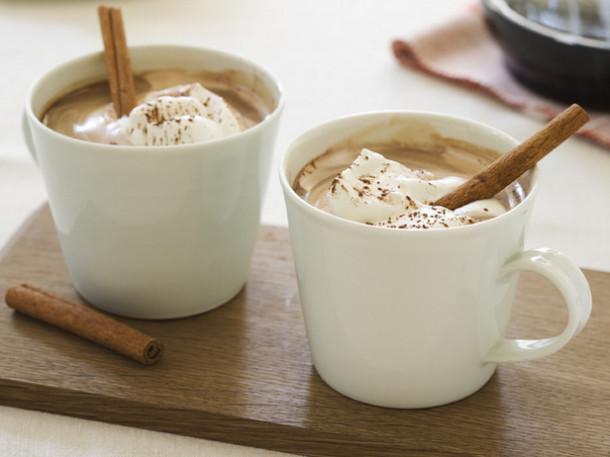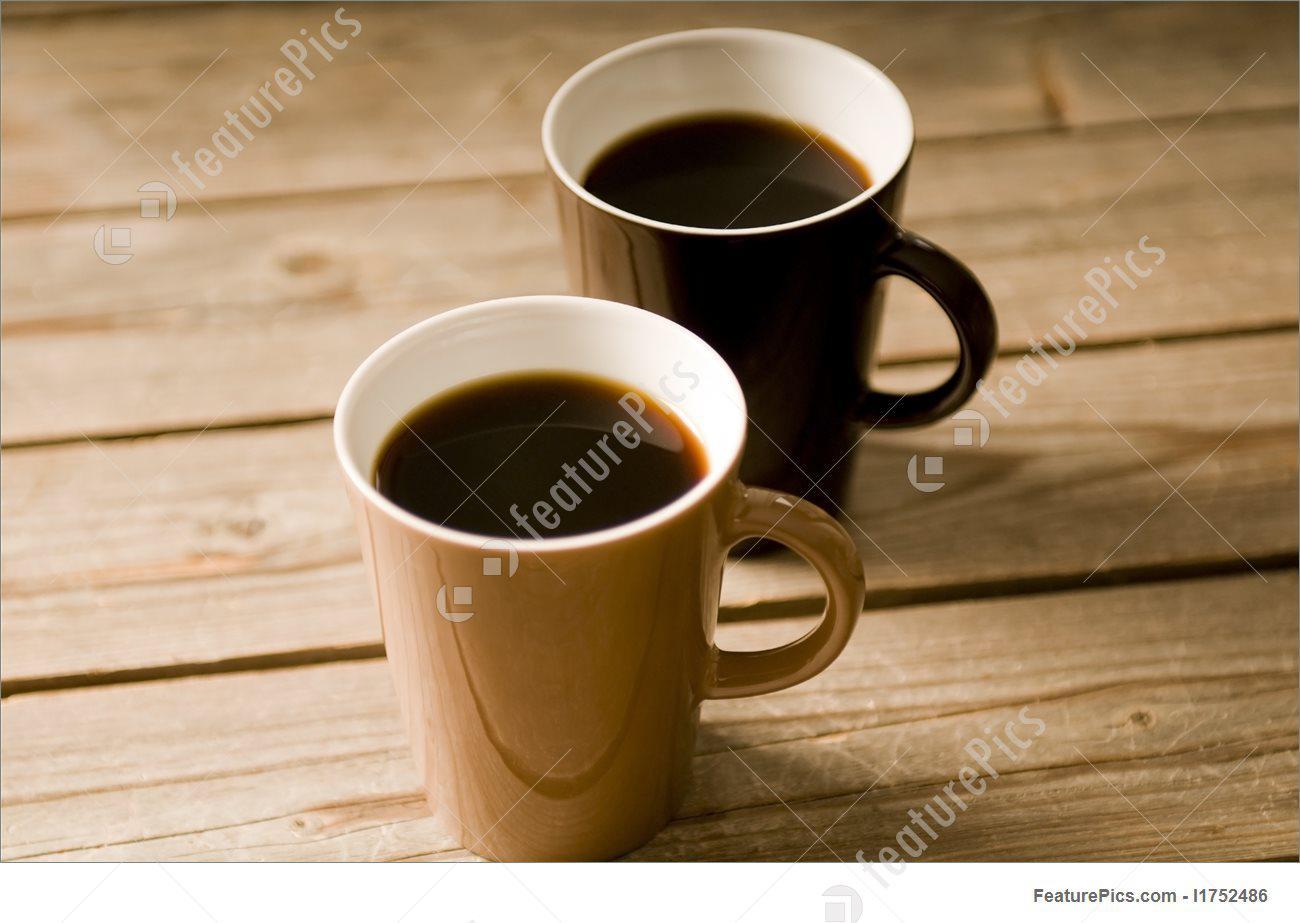The first image is the image on the left, the second image is the image on the right. Considering the images on both sides, is "At least one of the images does not contain any brown wood." valid? Answer yes or no. No. 